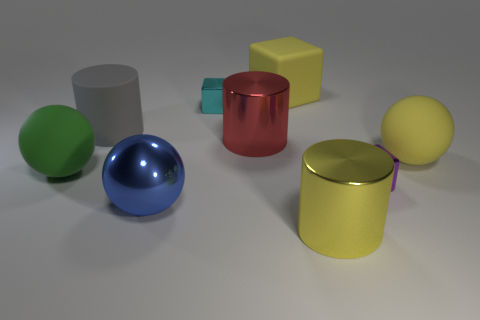What number of gray cylinders have the same material as the yellow block?
Give a very brief answer. 1. What color is the big ball that is made of the same material as the cyan cube?
Give a very brief answer. Blue. Is the color of the small shiny block that is behind the big rubber cylinder the same as the large matte cylinder?
Ensure brevity in your answer.  No. There is a tiny block left of the big rubber cube; what material is it?
Ensure brevity in your answer.  Metal. Are there the same number of green balls that are to the right of the big yellow metallic thing and gray matte cylinders?
Offer a very short reply. No. What number of large things are the same color as the large cube?
Provide a succinct answer. 2. The other rubber object that is the same shape as the cyan object is what color?
Your response must be concise. Yellow. Do the purple metal block and the green rubber ball have the same size?
Keep it short and to the point. No. Is the number of rubber cubes that are in front of the big red metal object the same as the number of yellow cubes that are in front of the large matte cylinder?
Keep it short and to the point. Yes. Are any big red metal things visible?
Your response must be concise. Yes. 